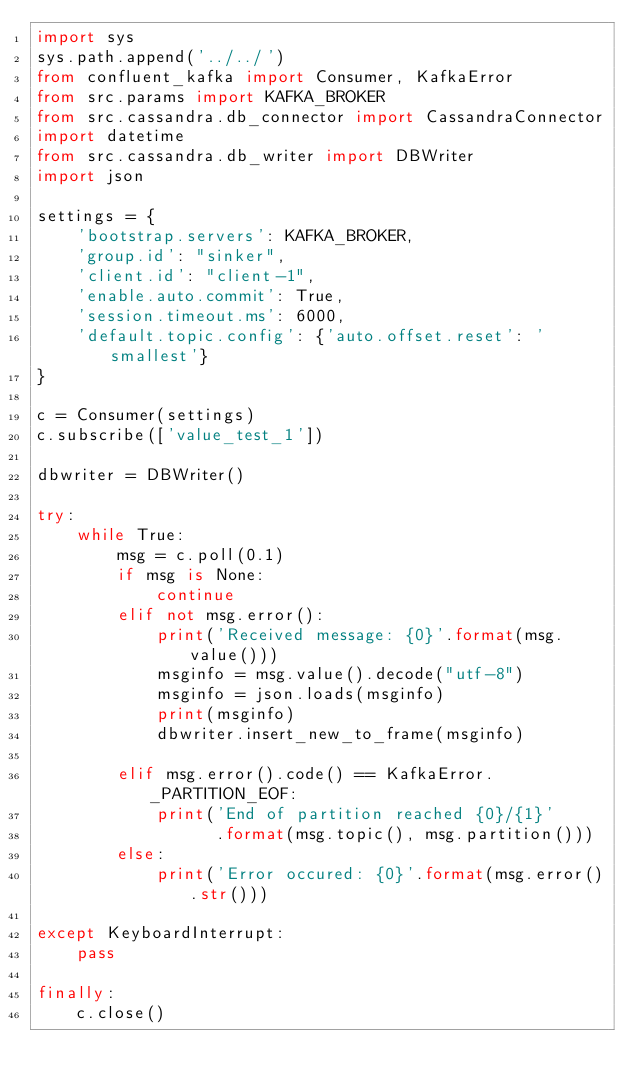Convert code to text. <code><loc_0><loc_0><loc_500><loc_500><_Python_>import sys
sys.path.append('../../')
from confluent_kafka import Consumer, KafkaError
from src.params import KAFKA_BROKER
from src.cassandra.db_connector import CassandraConnector
import datetime
from src.cassandra.db_writer import DBWriter
import json

settings = {
    'bootstrap.servers': KAFKA_BROKER,
    'group.id': "sinker",
    'client.id': "client-1",
    'enable.auto.commit': True,
    'session.timeout.ms': 6000,
    'default.topic.config': {'auto.offset.reset': 'smallest'}
}

c = Consumer(settings)
c.subscribe(['value_test_1'])

dbwriter = DBWriter()

try:
    while True:
        msg = c.poll(0.1)
        if msg is None:
            continue
        elif not msg.error():
            print('Received message: {0}'.format(msg.value()))
            msginfo = msg.value().decode("utf-8")
            msginfo = json.loads(msginfo)
            print(msginfo)
            dbwriter.insert_new_to_frame(msginfo)
            
        elif msg.error().code() == KafkaError._PARTITION_EOF:
            print('End of partition reached {0}/{1}'
                  .format(msg.topic(), msg.partition()))
        else:
            print('Error occured: {0}'.format(msg.error().str()))

except KeyboardInterrupt:
    pass

finally:
    c.close()
</code> 